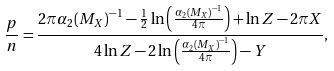Convert formula to latex. <formula><loc_0><loc_0><loc_500><loc_500>\frac { p } { n } = \frac { 2 \pi { \alpha _ { 2 } ( M _ { X } ) } ^ { - 1 } - \frac { 1 } { 2 } \ln \left ( \frac { { \alpha _ { 2 } ( M _ { X } ) } ^ { - 1 } } { 4 \pi } \right ) + \ln Z - 2 \pi X } { 4 \ln Z - 2 \ln \left ( \frac { { \alpha _ { 2 } ( M _ { X } ) } ^ { - 1 } } { 4 \pi } \right ) - Y } ,</formula> 